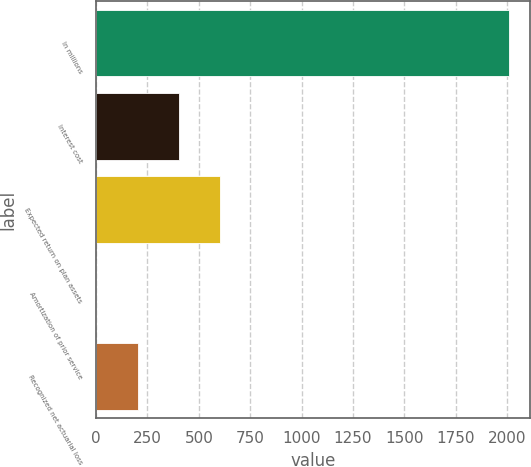Convert chart to OTSL. <chart><loc_0><loc_0><loc_500><loc_500><bar_chart><fcel>In millions<fcel>Interest cost<fcel>Expected return on plan assets<fcel>Amortization of prior service<fcel>Recognized net actuarial loss<nl><fcel>2009<fcel>402.6<fcel>603.4<fcel>1<fcel>201.8<nl></chart> 